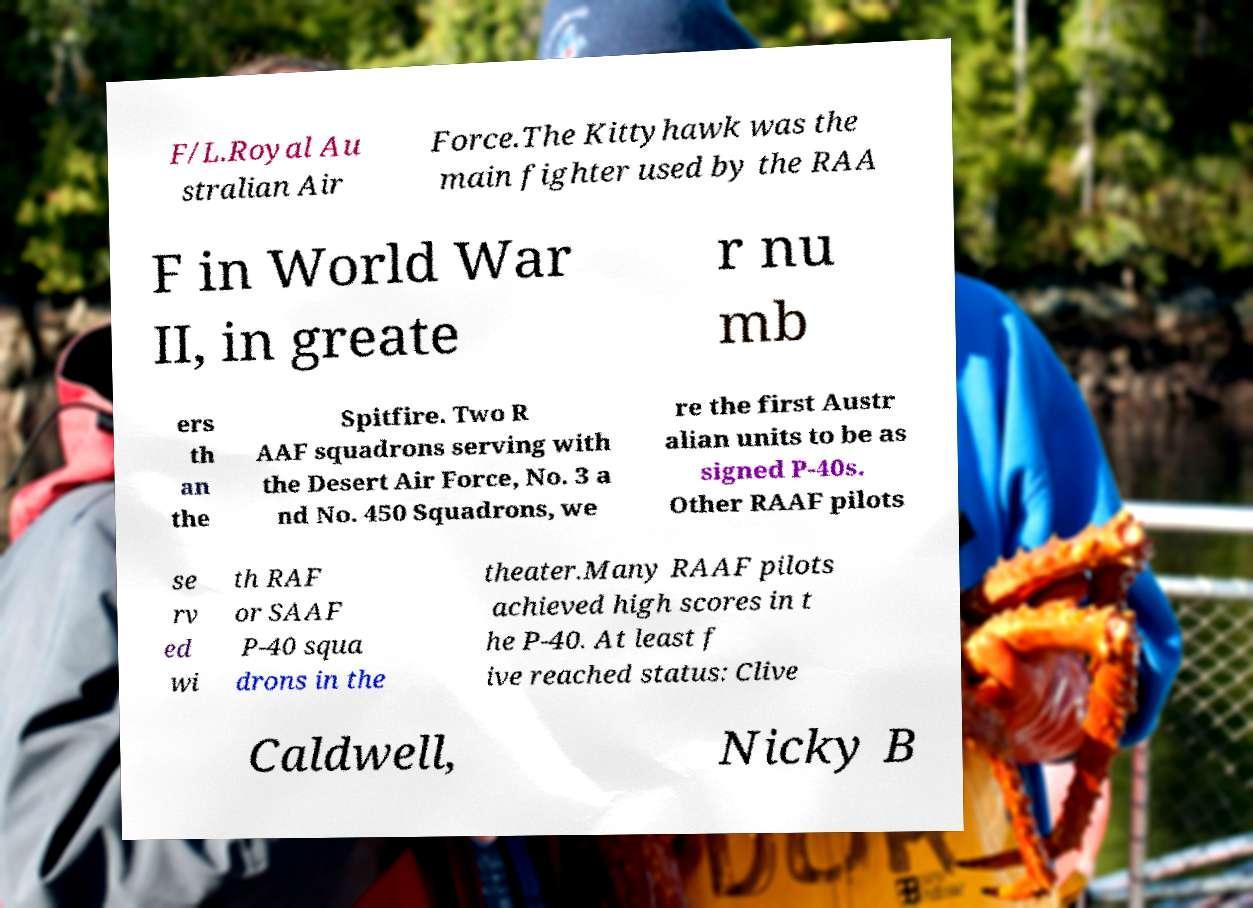Could you assist in decoding the text presented in this image and type it out clearly? F/L.Royal Au stralian Air Force.The Kittyhawk was the main fighter used by the RAA F in World War II, in greate r nu mb ers th an the Spitfire. Two R AAF squadrons serving with the Desert Air Force, No. 3 a nd No. 450 Squadrons, we re the first Austr alian units to be as signed P-40s. Other RAAF pilots se rv ed wi th RAF or SAAF P-40 squa drons in the theater.Many RAAF pilots achieved high scores in t he P-40. At least f ive reached status: Clive Caldwell, Nicky B 